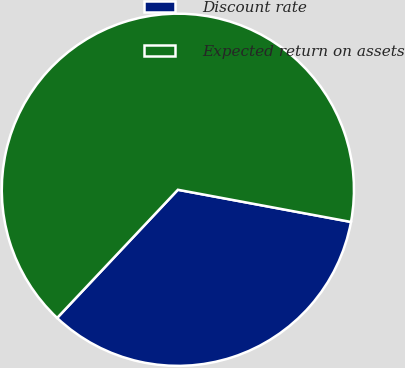<chart> <loc_0><loc_0><loc_500><loc_500><pie_chart><fcel>Discount rate<fcel>Expected return on assets<nl><fcel>34.1%<fcel>65.9%<nl></chart> 